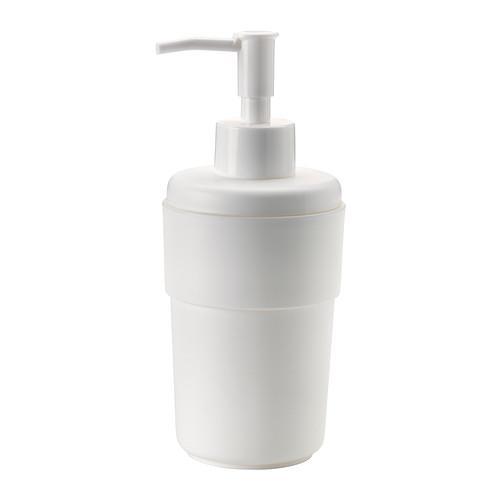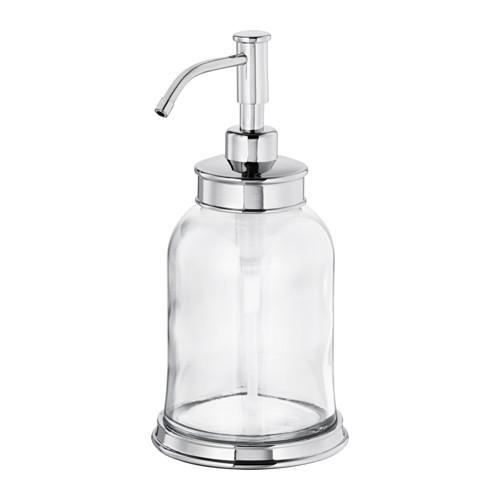The first image is the image on the left, the second image is the image on the right. For the images displayed, is the sentence "The left and right image contains the same number of sink soap dispensers with one sold bottle." factually correct? Answer yes or no. Yes. The first image is the image on the left, the second image is the image on the right. Assess this claim about the two images: "Both dispensers have silver colored nozzles.". Correct or not? Answer yes or no. No. 